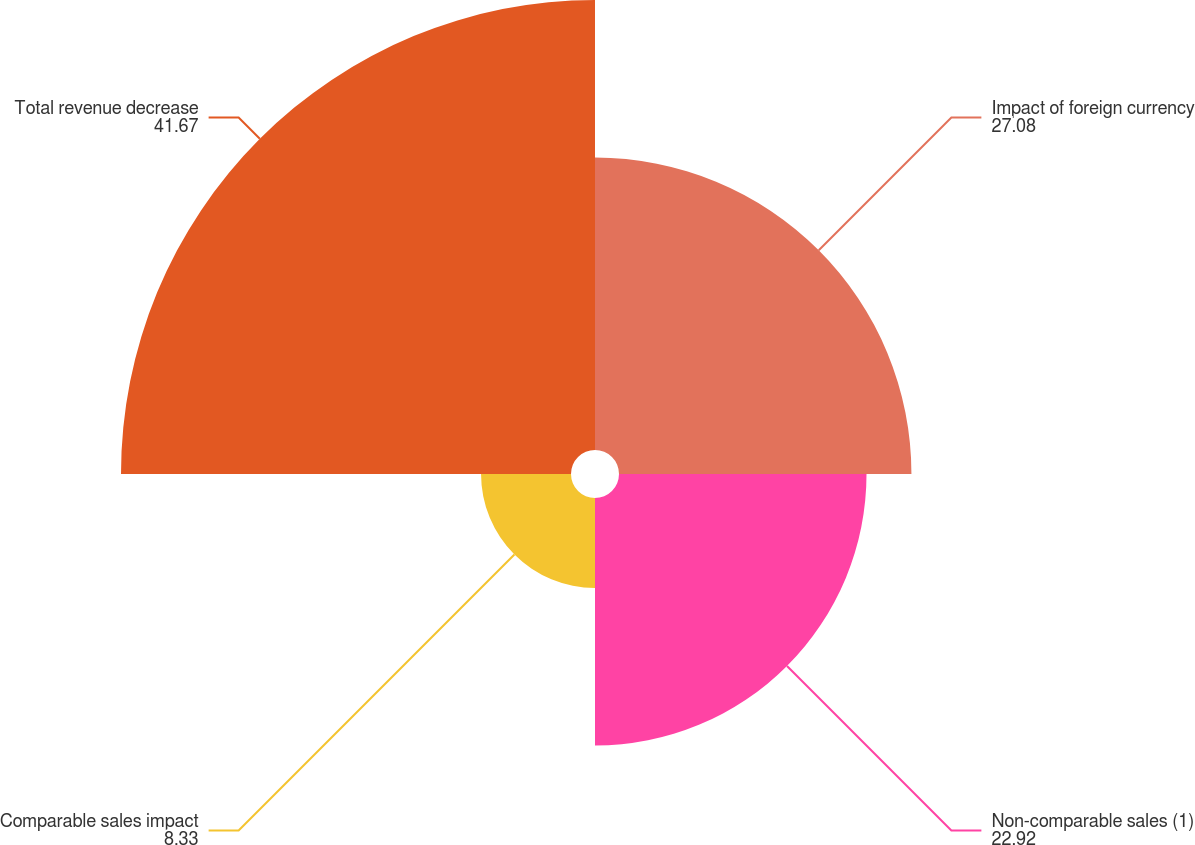Convert chart. <chart><loc_0><loc_0><loc_500><loc_500><pie_chart><fcel>Impact of foreign currency<fcel>Non-comparable sales (1)<fcel>Comparable sales impact<fcel>Total revenue decrease<nl><fcel>27.08%<fcel>22.92%<fcel>8.33%<fcel>41.67%<nl></chart> 